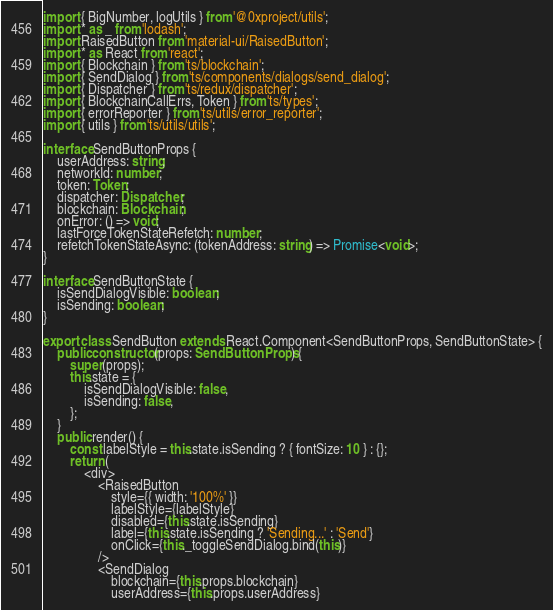<code> <loc_0><loc_0><loc_500><loc_500><_TypeScript_>import { BigNumber, logUtils } from '@0xproject/utils';
import * as _ from 'lodash';
import RaisedButton from 'material-ui/RaisedButton';
import * as React from 'react';
import { Blockchain } from 'ts/blockchain';
import { SendDialog } from 'ts/components/dialogs/send_dialog';
import { Dispatcher } from 'ts/redux/dispatcher';
import { BlockchainCallErrs, Token } from 'ts/types';
import { errorReporter } from 'ts/utils/error_reporter';
import { utils } from 'ts/utils/utils';

interface SendButtonProps {
    userAddress: string;
    networkId: number;
    token: Token;
    dispatcher: Dispatcher;
    blockchain: Blockchain;
    onError: () => void;
    lastForceTokenStateRefetch: number;
    refetchTokenStateAsync: (tokenAddress: string) => Promise<void>;
}

interface SendButtonState {
    isSendDialogVisible: boolean;
    isSending: boolean;
}

export class SendButton extends React.Component<SendButtonProps, SendButtonState> {
    public constructor(props: SendButtonProps) {
        super(props);
        this.state = {
            isSendDialogVisible: false,
            isSending: false,
        };
    }
    public render() {
        const labelStyle = this.state.isSending ? { fontSize: 10 } : {};
        return (
            <div>
                <RaisedButton
                    style={{ width: '100%' }}
                    labelStyle={labelStyle}
                    disabled={this.state.isSending}
                    label={this.state.isSending ? 'Sending...' : 'Send'}
                    onClick={this._toggleSendDialog.bind(this)}
                />
                <SendDialog
                    blockchain={this.props.blockchain}
                    userAddress={this.props.userAddress}</code> 